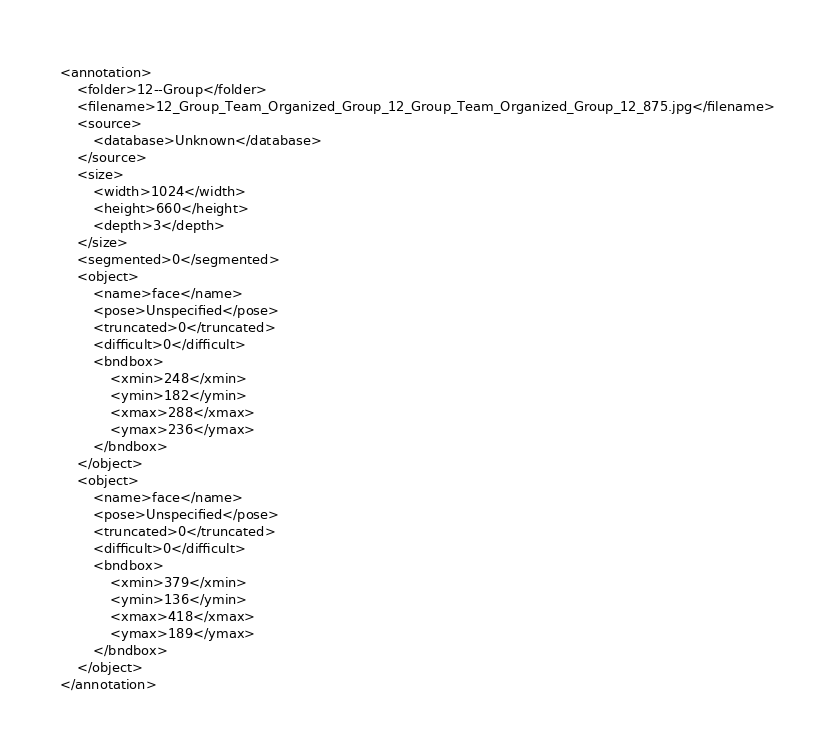<code> <loc_0><loc_0><loc_500><loc_500><_XML_><annotation>
    <folder>12--Group</folder>
    <filename>12_Group_Team_Organized_Group_12_Group_Team_Organized_Group_12_875.jpg</filename>
    <source>
        <database>Unknown</database>
    </source>
    <size>
        <width>1024</width>
        <height>660</height>
        <depth>3</depth>
    </size>
    <segmented>0</segmented>
    <object>
        <name>face</name>
        <pose>Unspecified</pose>
        <truncated>0</truncated>
        <difficult>0</difficult>
        <bndbox>
            <xmin>248</xmin>
            <ymin>182</ymin>
            <xmax>288</xmax>
            <ymax>236</ymax>
        </bndbox>
    </object>
    <object>
        <name>face</name>
        <pose>Unspecified</pose>
        <truncated>0</truncated>
        <difficult>0</difficult>
        <bndbox>
            <xmin>379</xmin>
            <ymin>136</ymin>
            <xmax>418</xmax>
            <ymax>189</ymax>
        </bndbox>
    </object>
</annotation>
</code> 